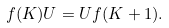<formula> <loc_0><loc_0><loc_500><loc_500>f ( K ) U = U f ( K + 1 ) .</formula> 